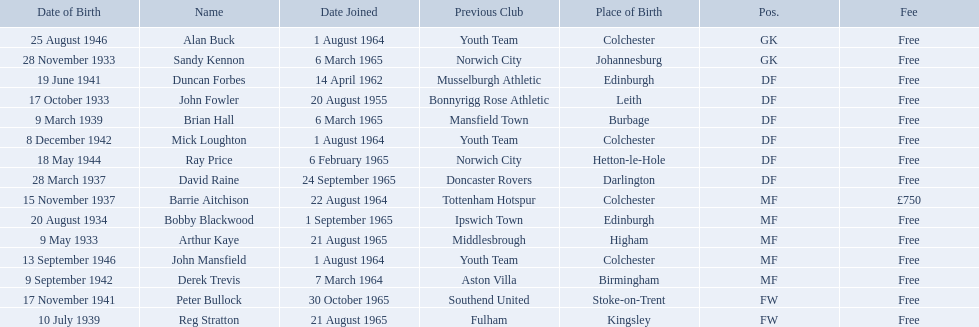When did alan buck join the colchester united f.c. in 1965-66? 1 August 1964. When did the last player to join? Peter Bullock. What date did the first player join? 20 August 1955. 